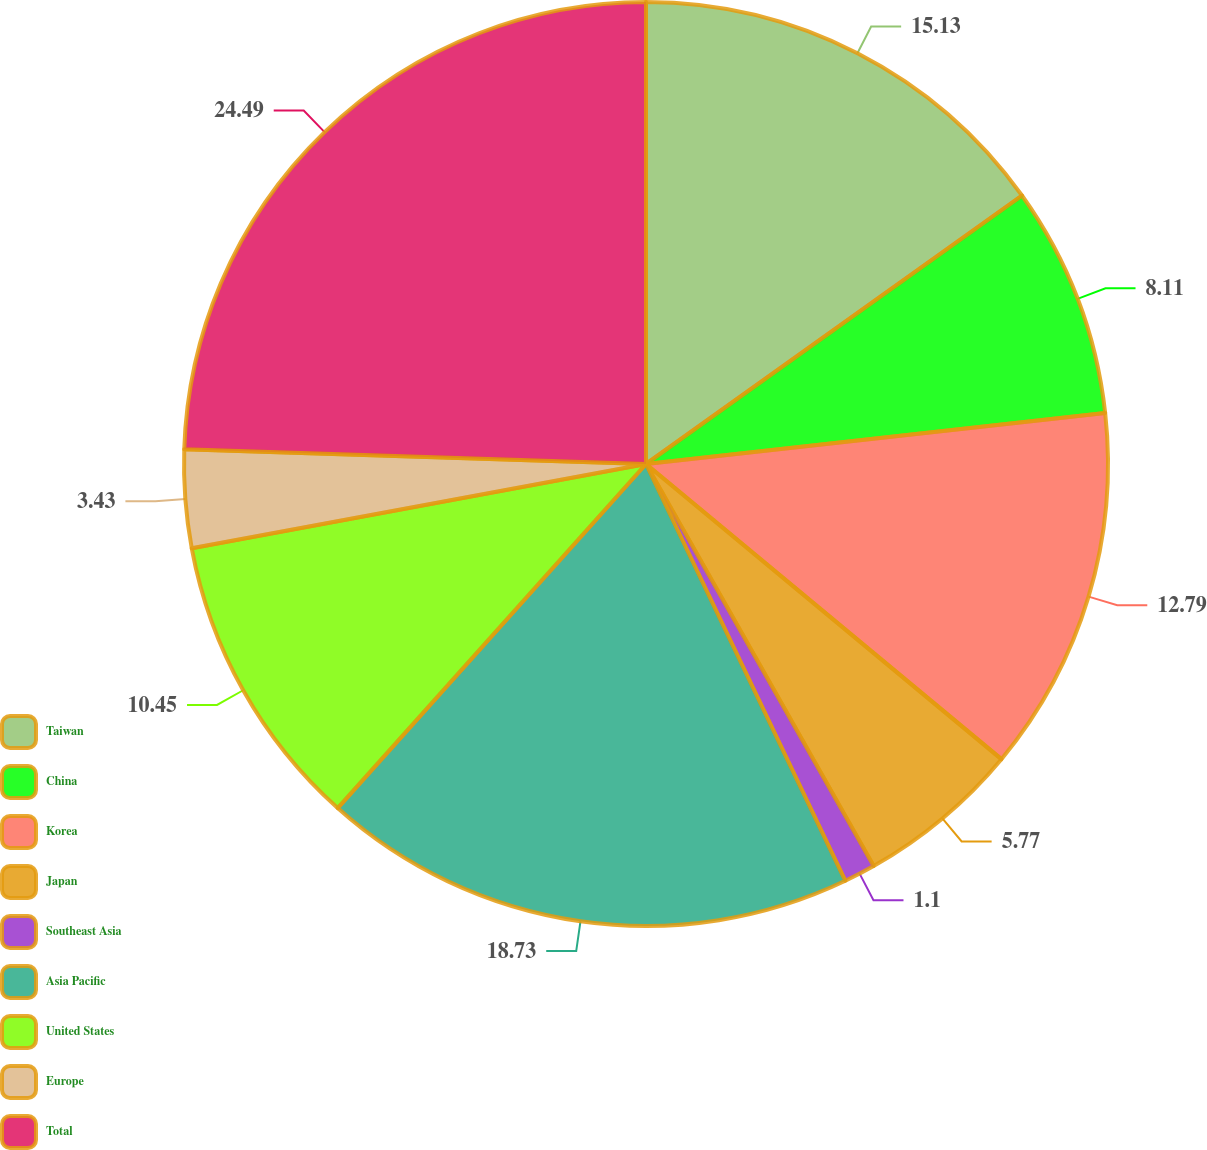Convert chart to OTSL. <chart><loc_0><loc_0><loc_500><loc_500><pie_chart><fcel>Taiwan<fcel>China<fcel>Korea<fcel>Japan<fcel>Southeast Asia<fcel>Asia Pacific<fcel>United States<fcel>Europe<fcel>Total<nl><fcel>15.13%<fcel>8.11%<fcel>12.79%<fcel>5.77%<fcel>1.1%<fcel>18.73%<fcel>10.45%<fcel>3.43%<fcel>24.49%<nl></chart> 